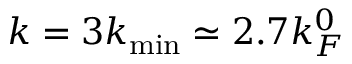<formula> <loc_0><loc_0><loc_500><loc_500>k = 3 k _ { \min } \simeq 2 . 7 k _ { F } ^ { 0 }</formula> 